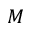Convert formula to latex. <formula><loc_0><loc_0><loc_500><loc_500>M</formula> 